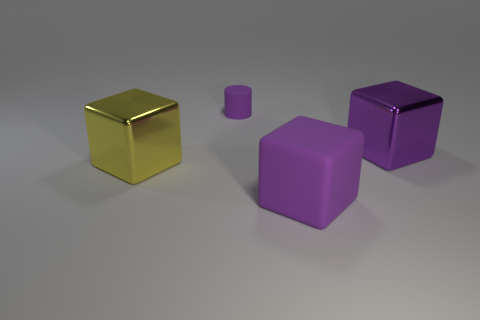Add 4 large purple blocks. How many objects exist? 8 Subtract all cylinders. How many objects are left? 3 Add 1 large yellow objects. How many large yellow objects are left? 2 Add 4 small rubber cylinders. How many small rubber cylinders exist? 5 Subtract 1 yellow cubes. How many objects are left? 3 Subtract all big yellow metallic things. Subtract all tiny cylinders. How many objects are left? 2 